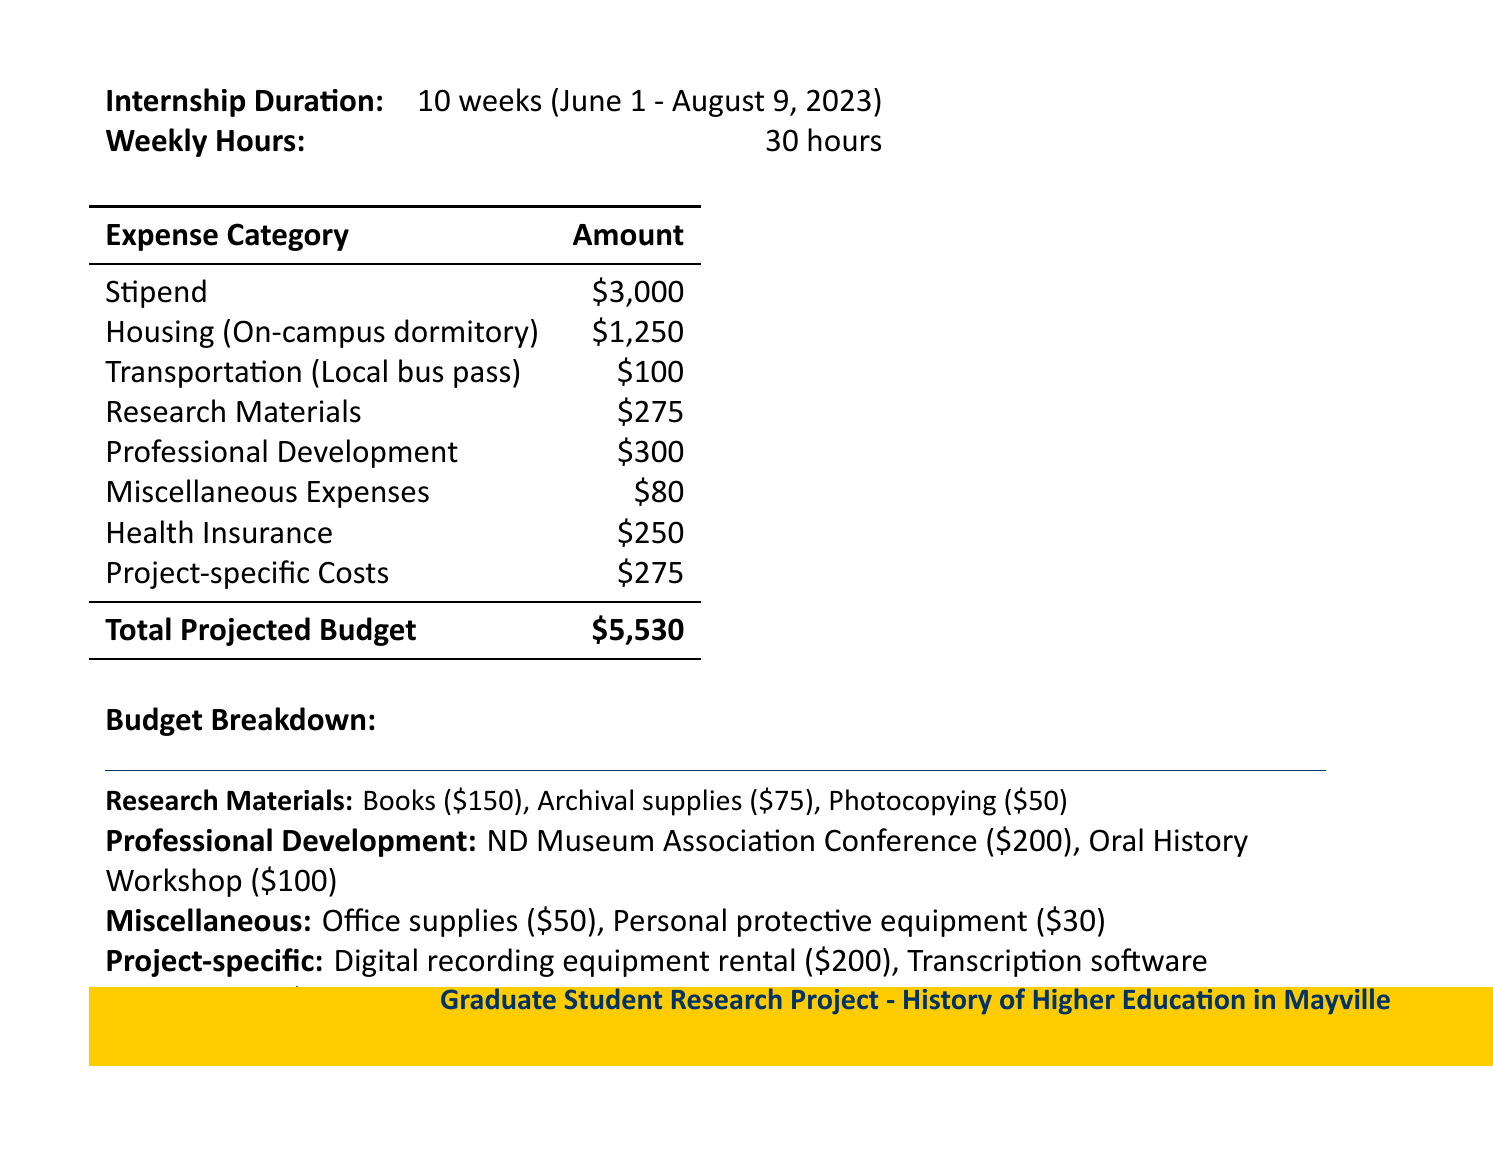What is the duration of the internship? The duration is specified in the document as 10 weeks, running from June 1 to August 9, 2023.
Answer: 10 weeks What is the weekly hour commitment for the internship? The document states that the intern will work 30 hours per week.
Answer: 30 hours What is the amount allocated for housing? The housing cost is detailed in the budget as \$1,250 for an on-campus dormitory.
Answer: $1,250 What is the total projected budget for the summer internship? The total is calculated as the sum of all expenses listed in the document, which is \$5,530.
Answer: $5,530 How much is allocated for research materials? The budget explicitly states \$275 is designated for research materials.
Answer: $275 Which expense category has the highest allocation? By comparing the amounts listed, the stipend category has the highest allocation at \$3,000.
Answer: Stipend What are the specific costs for professional development? The breakdown shows \$200 for the ND Museum Association Conference and \$100 for the Oral History Workshop, totaling \$300.
Answer: $300 What type of equipment is included under project-specific costs? The project-specific costs include digital recording equipment rental and transcription software subscription.
Answer: Digital recording equipment What are miscellaneous expenses budgeted for? The miscellaneous expenses budget includes office supplies and personal protective equipment, totaling \$80.
Answer: Office supplies and personal protective equipment How much is budgeted for health insurance? The document shows \$250 is allocated for health insurance.
Answer: $250 